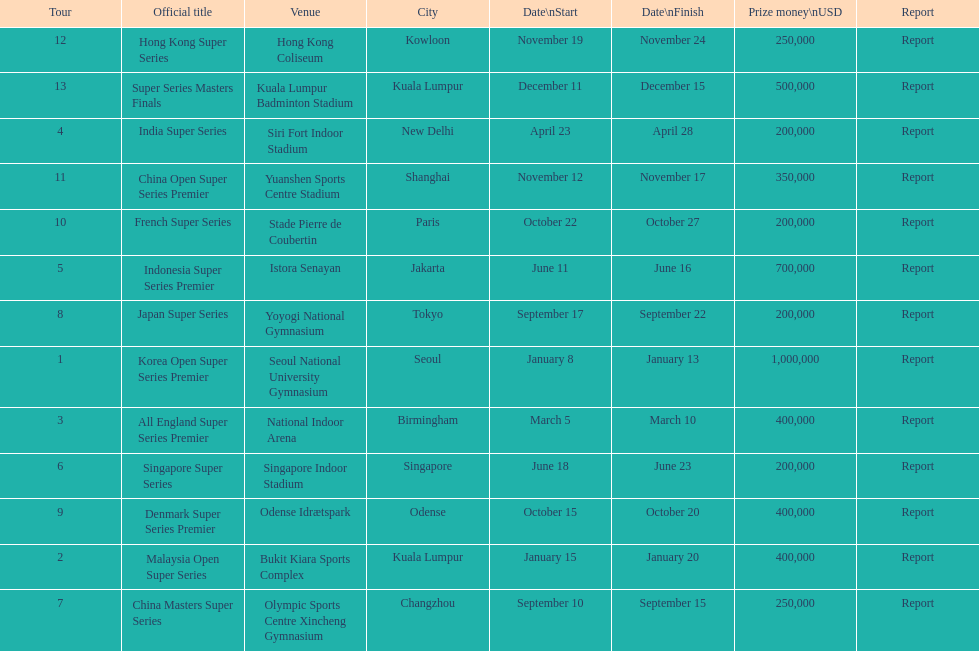Which tour was the only one to take place in december? Super Series Masters Finals. 